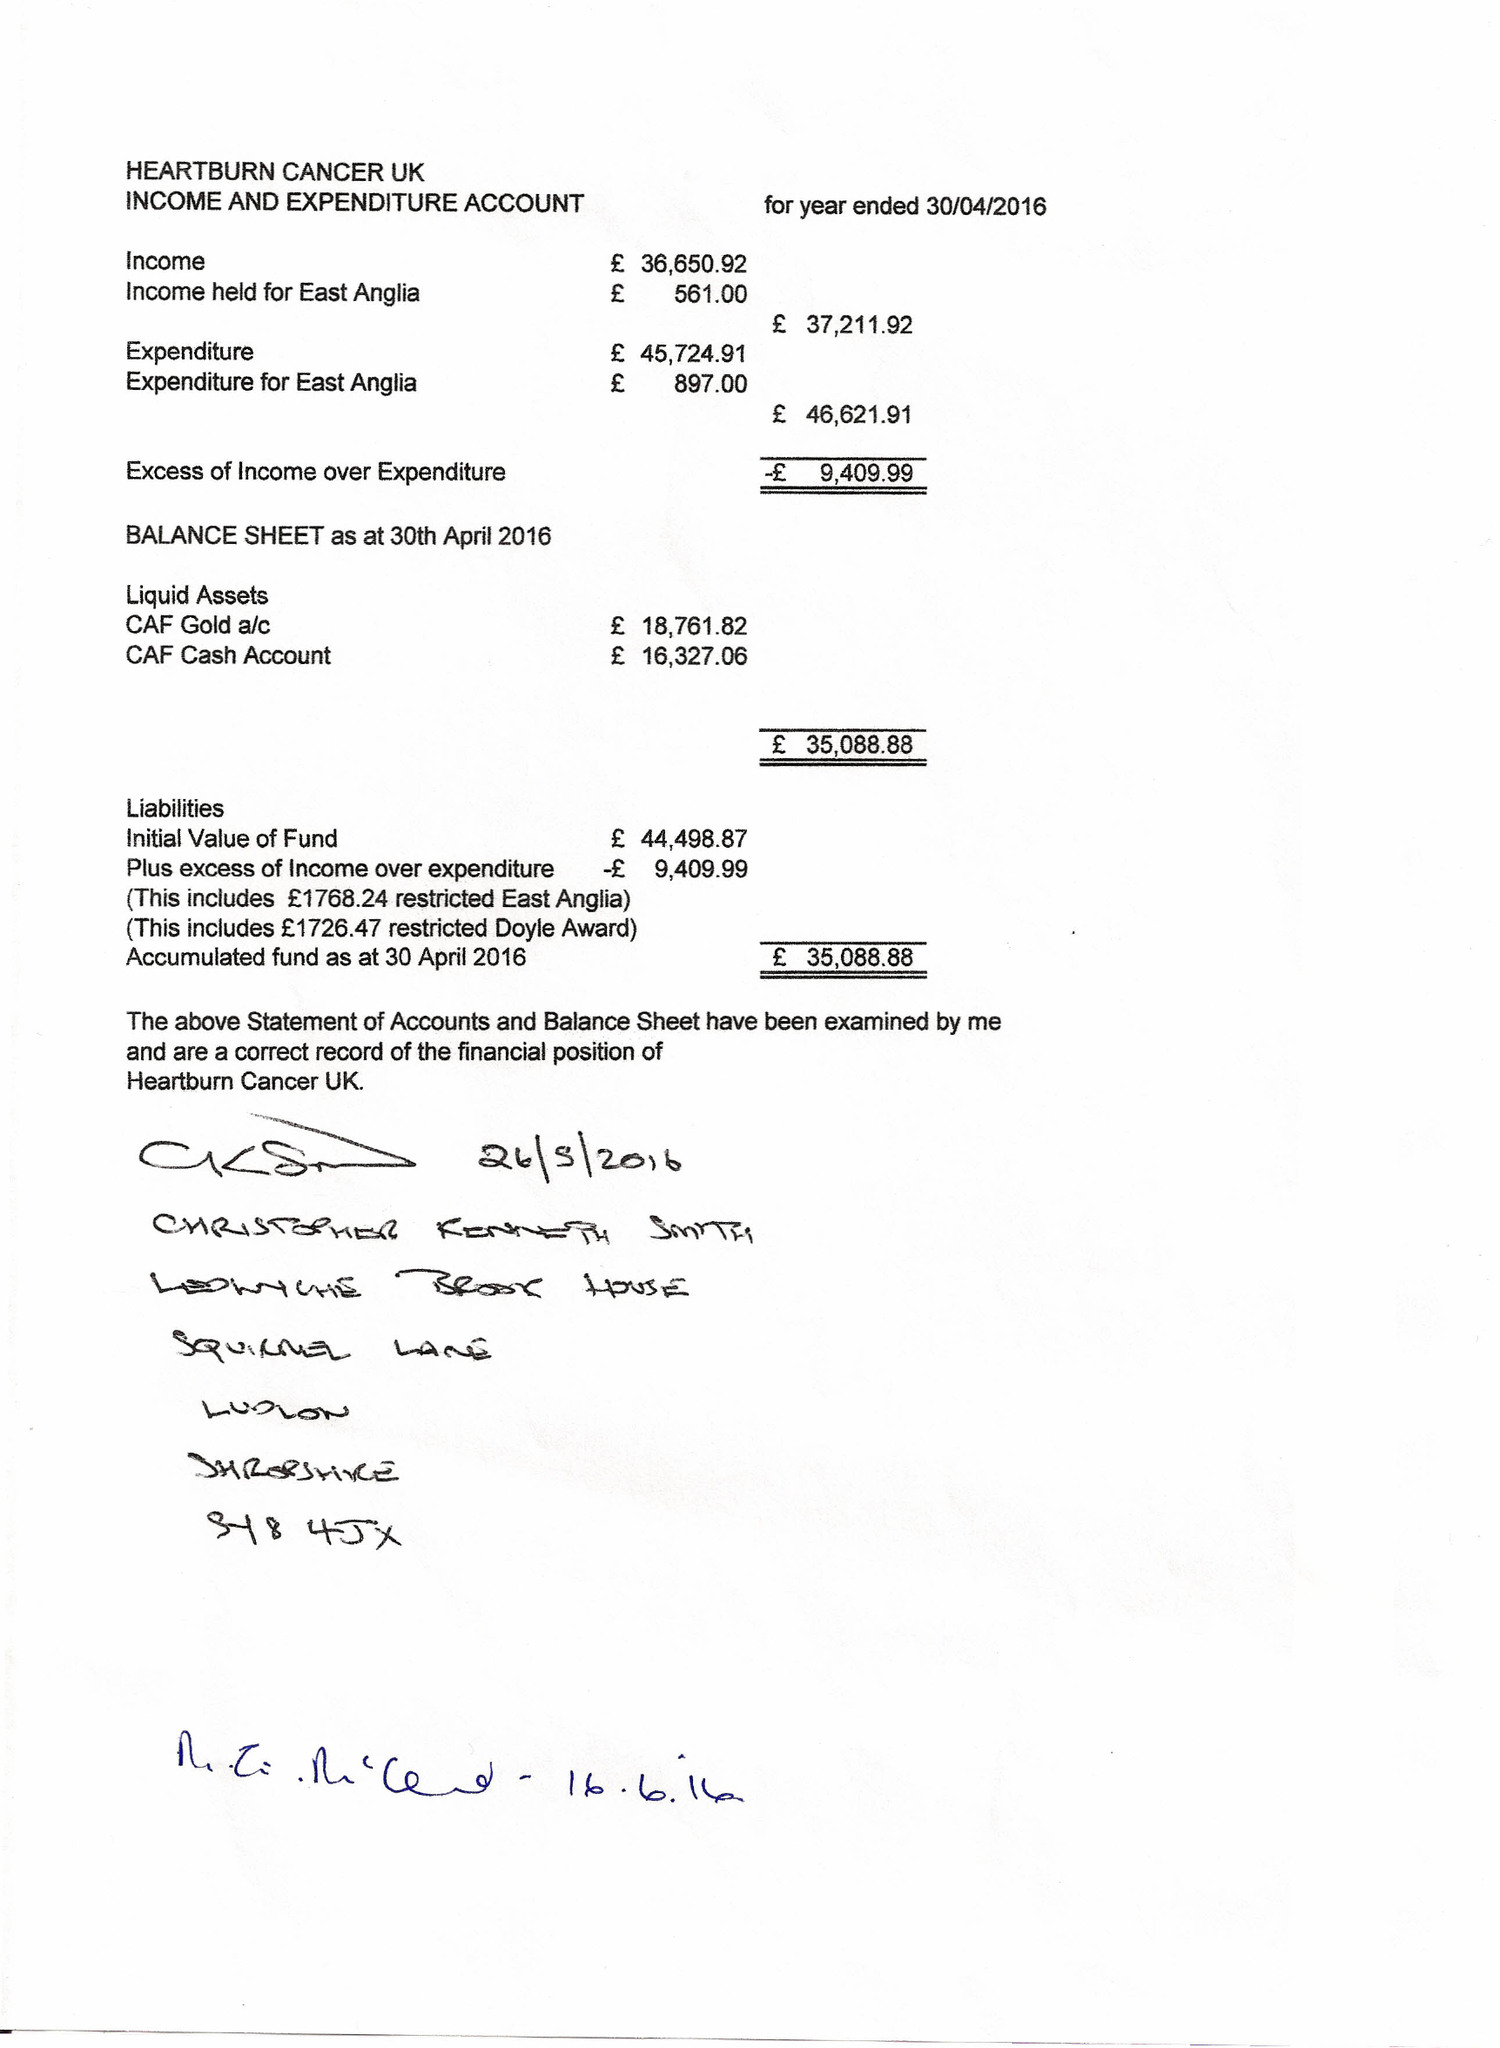What is the value for the report_date?
Answer the question using a single word or phrase. 2016-04-30 